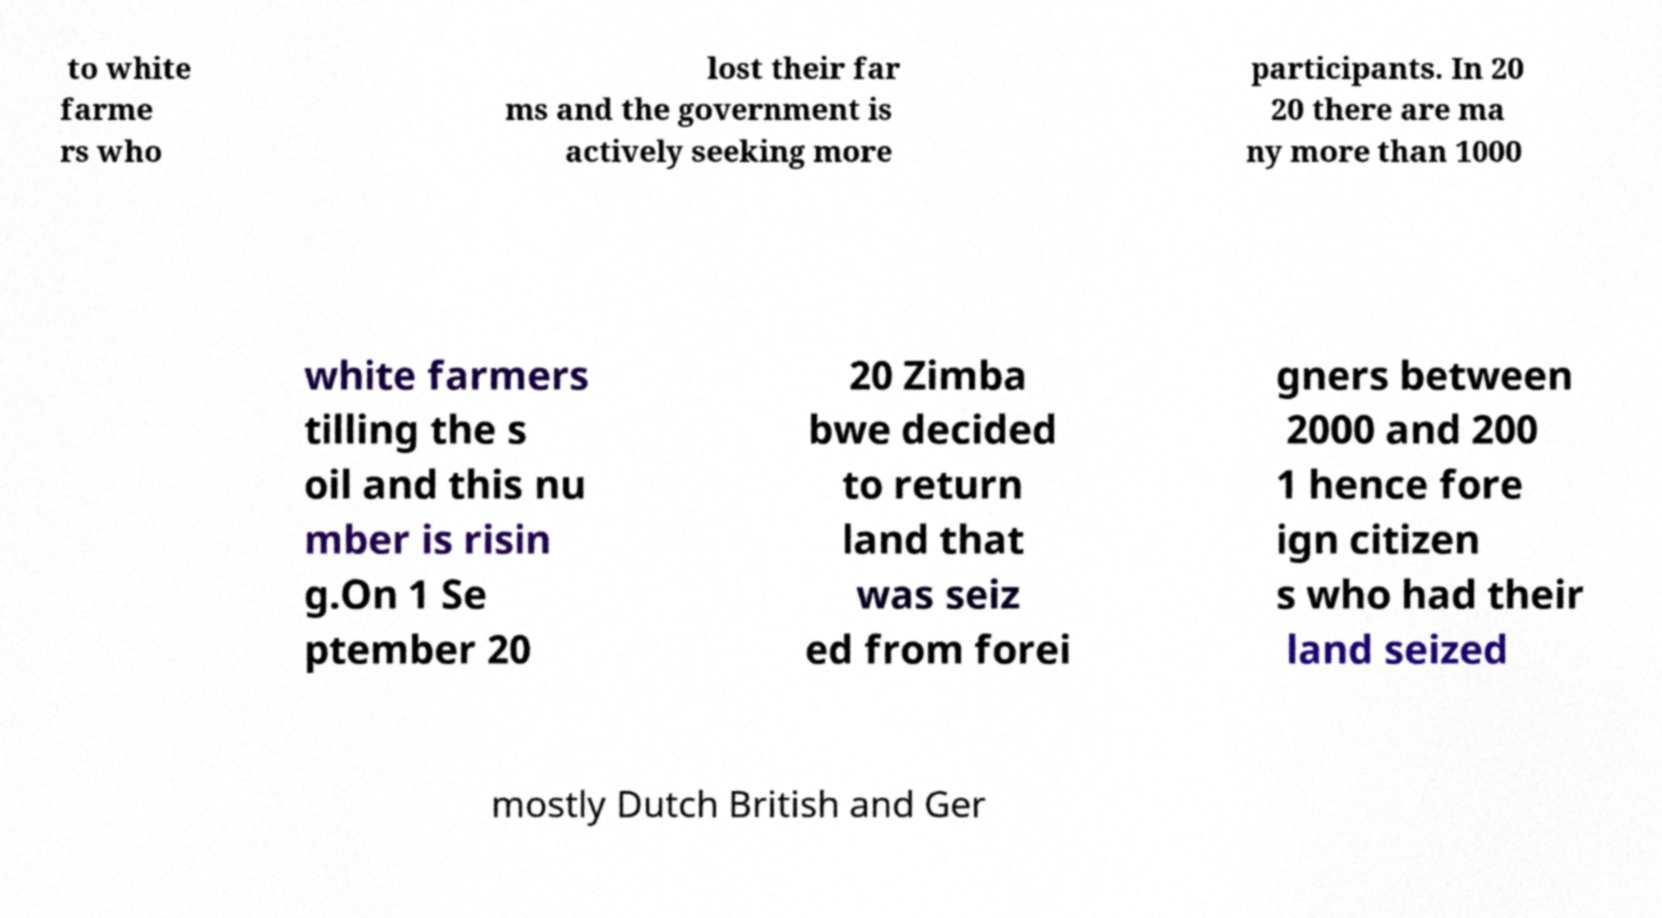For documentation purposes, I need the text within this image transcribed. Could you provide that? to white farme rs who lost their far ms and the government is actively seeking more participants. In 20 20 there are ma ny more than 1000 white farmers tilling the s oil and this nu mber is risin g.On 1 Se ptember 20 20 Zimba bwe decided to return land that was seiz ed from forei gners between 2000 and 200 1 hence fore ign citizen s who had their land seized mostly Dutch British and Ger 